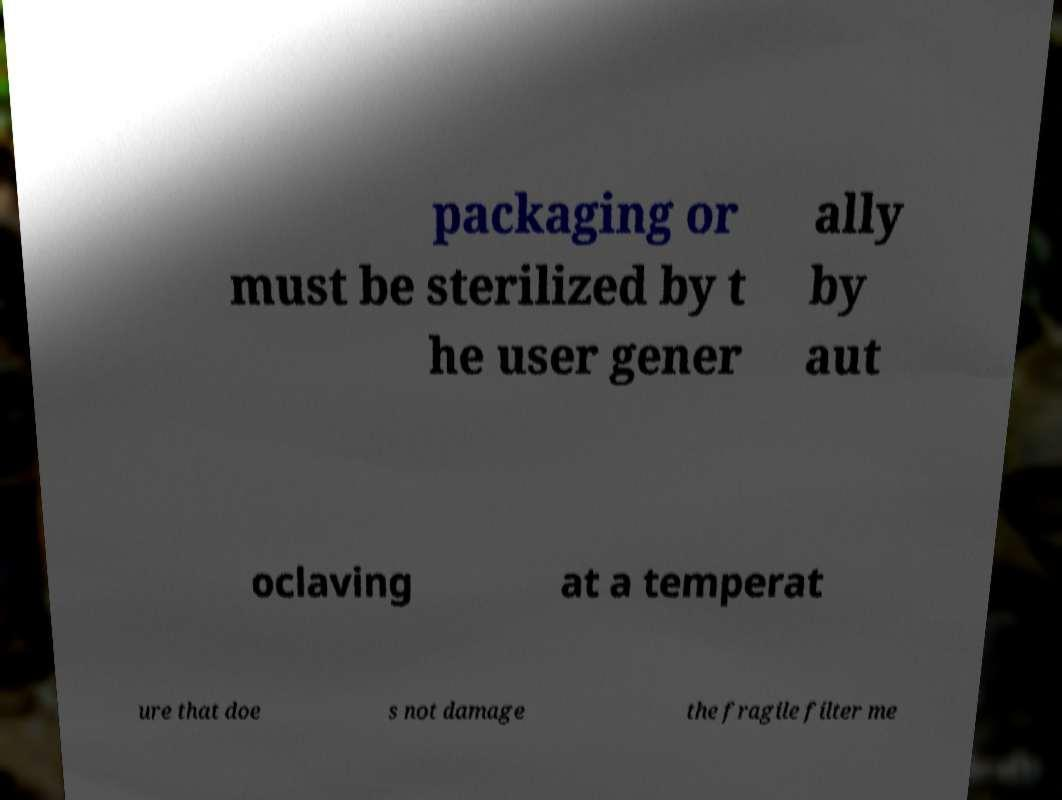For documentation purposes, I need the text within this image transcribed. Could you provide that? packaging or must be sterilized by t he user gener ally by aut oclaving at a temperat ure that doe s not damage the fragile filter me 